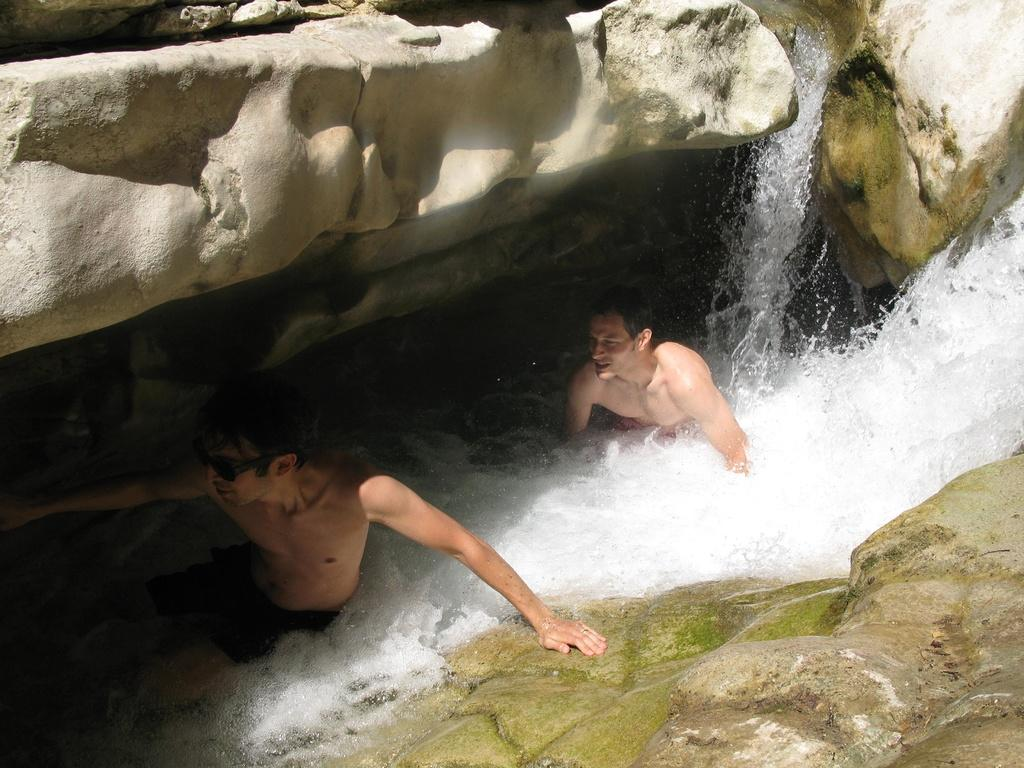How many people are in the image? There are two people in the image. What is one person wearing that is not typical for everyday wear? One person is wearing a goggle. What is the primary element visible in the image? There is water visible in the image. What type of natural formation can be seen in the image? There are rocks in the image. What type of dress is the person wearing in the image? There is no dress present in the image; one person is wearing a goggle. How is the distribution of trains in the image? There are no trains present in the image. 